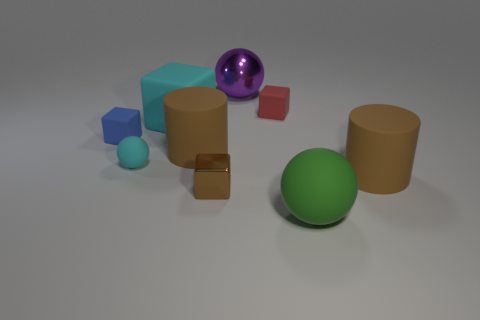Subtract all blocks. How many objects are left? 5 Subtract all big cylinders. Subtract all large matte spheres. How many objects are left? 6 Add 7 cyan matte cubes. How many cyan matte cubes are left? 8 Add 9 small brown rubber balls. How many small brown rubber balls exist? 9 Subtract 1 brown cylinders. How many objects are left? 8 